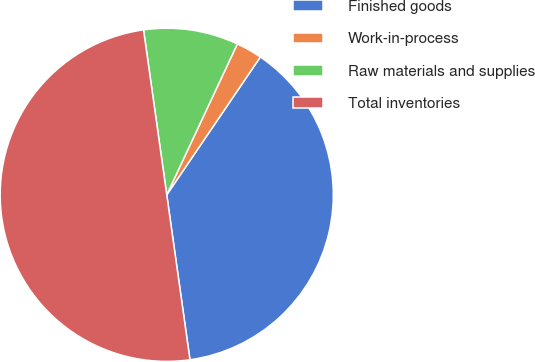Convert chart to OTSL. <chart><loc_0><loc_0><loc_500><loc_500><pie_chart><fcel>Finished goods<fcel>Work-in-process<fcel>Raw materials and supplies<fcel>Total inventories<nl><fcel>38.28%<fcel>2.53%<fcel>9.19%<fcel>50.0%<nl></chart> 